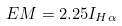<formula> <loc_0><loc_0><loc_500><loc_500>E M = 2 . 2 5 I _ { H \alpha }</formula> 